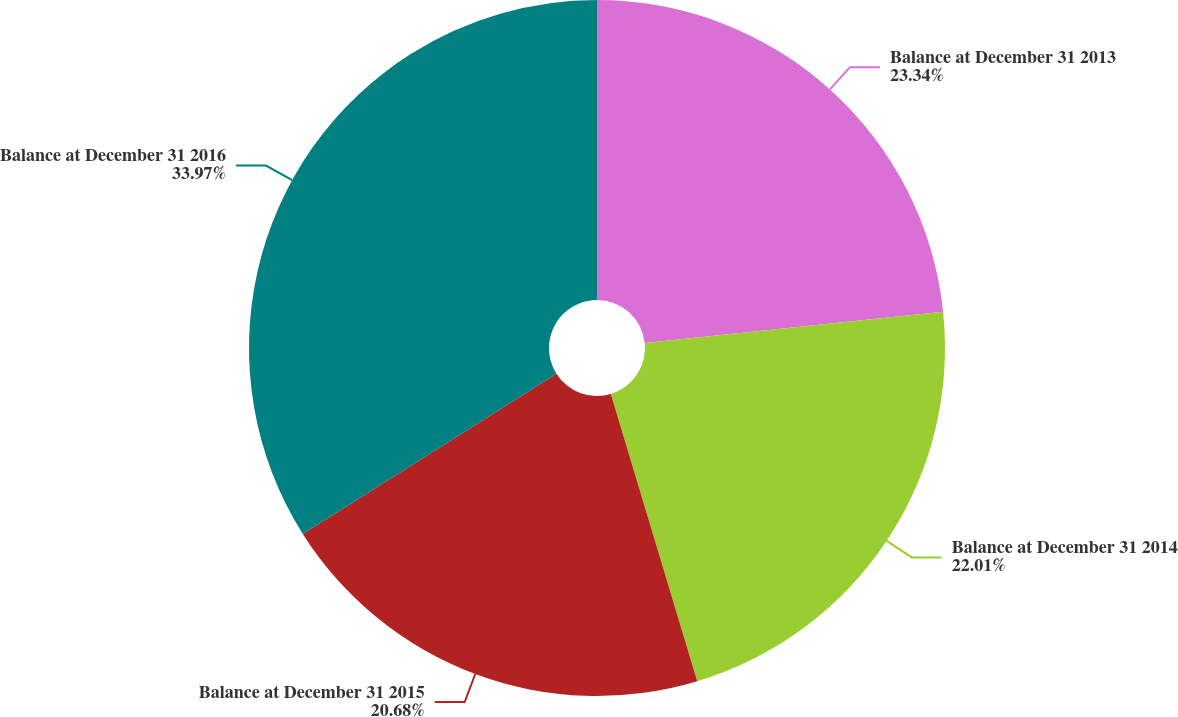Convert chart to OTSL. <chart><loc_0><loc_0><loc_500><loc_500><pie_chart><fcel>Balance at December 31 2013<fcel>Balance at December 31 2014<fcel>Balance at December 31 2015<fcel>Balance at December 31 2016<nl><fcel>23.34%<fcel>22.01%<fcel>20.68%<fcel>33.97%<nl></chart> 